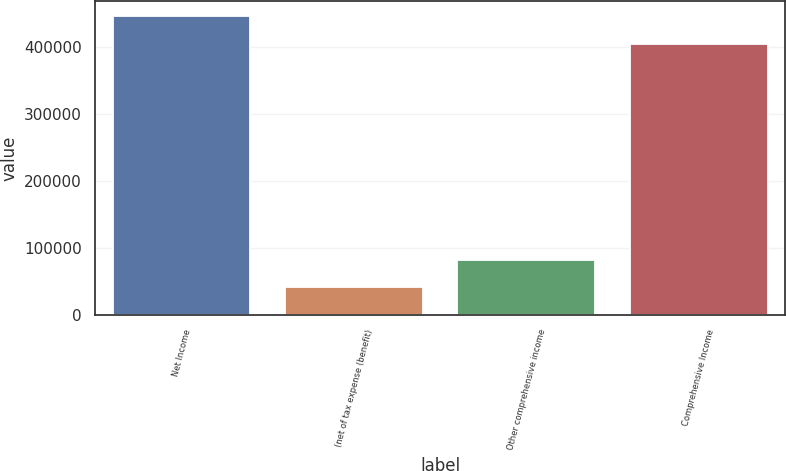<chart> <loc_0><loc_0><loc_500><loc_500><bar_chart><fcel>Net Income<fcel>(net of tax expense (benefit)<fcel>Other comprehensive income<fcel>Comprehensive Income<nl><fcel>446022<fcel>41386<fcel>81849.6<fcel>404636<nl></chart> 